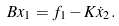<formula> <loc_0><loc_0><loc_500><loc_500>B x _ { 1 } = f _ { 1 } - K \dot { x } _ { 2 } .</formula> 